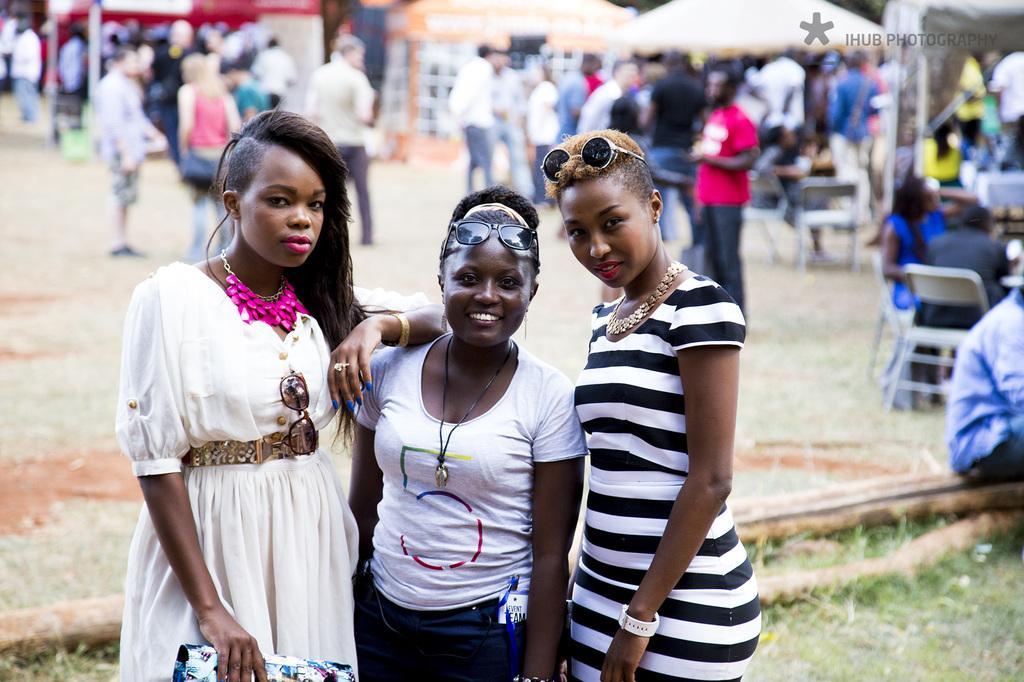Can you describe this image briefly? In this image, we can see people and some are wearing glasses and one of them is holding an object. In the background, there are tents, chairs and we can see some other objects. At the top, there is some text and a logo and at the bottom, there is ground and logs. 